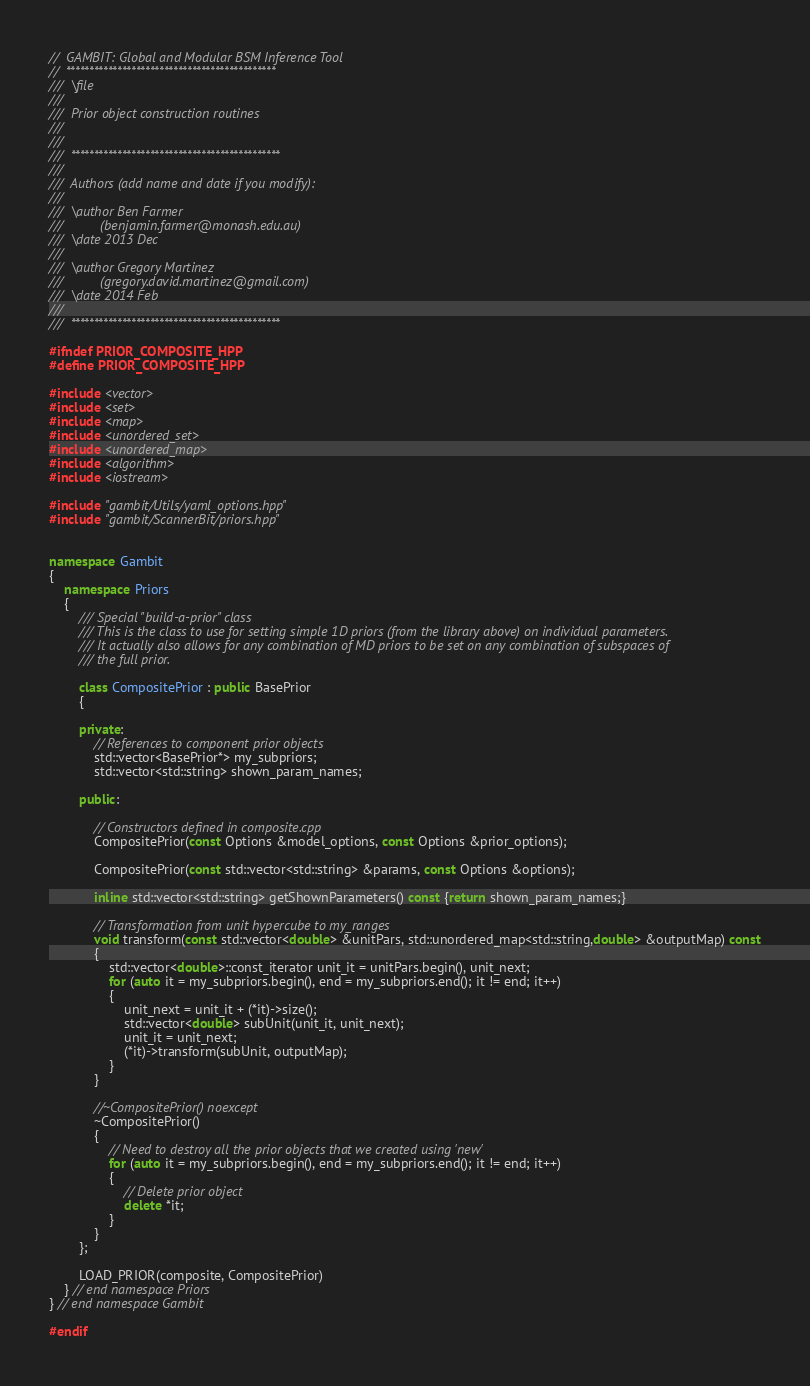Convert code to text. <code><loc_0><loc_0><loc_500><loc_500><_C++_>//  GAMBIT: Global and Modular BSM Inference Tool
//  *********************************************
///  \file
///
///  Prior object construction routines
///  
///
///  *********************************************
///
///  Authors (add name and date if you modify):
///   
///  \author Ben Farmer
///          (benjamin.farmer@monash.edu.au)
///  \date 2013 Dec
///
///  \author Gregory Martinez
///          (gregory.david.martinez@gmail.com)
///  \date 2014 Feb
///
///  *********************************************

#ifndef PRIOR_COMPOSITE_HPP
#define PRIOR_COMPOSITE_HPP

#include <vector>
#include <set>
#include <map>
#include <unordered_set>
#include <unordered_map>
#include <algorithm>
#include <iostream>

#include "gambit/Utils/yaml_options.hpp"
#include "gambit/ScannerBit/priors.hpp"


namespace Gambit 
{
    namespace Priors 
    {
        /// Special "build-a-prior" class
        /// This is the class to use for setting simple 1D priors (from the library above) on individual parameters.
        /// It actually also allows for any combination of MD priors to be set on any combination of subspaces of
        /// the full prior.

        class CompositePrior : public BasePrior
        {
                        
        private:
            // References to component prior objects
            std::vector<BasePrior*> my_subpriors;
            std::vector<std::string> shown_param_names;
                
        public:
        
            // Constructors defined in composite.cpp
            CompositePrior(const Options &model_options, const Options &prior_options);
            
            CompositePrior(const std::vector<std::string> &params, const Options &options);
            
            inline std::vector<std::string> getShownParameters() const {return shown_param_names;}
            
            // Transformation from unit hypercube to my_ranges
            void transform(const std::vector<double> &unitPars, std::unordered_map<std::string,double> &outputMap) const
            {
                std::vector<double>::const_iterator unit_it = unitPars.begin(), unit_next;
                for (auto it = my_subpriors.begin(), end = my_subpriors.end(); it != end; it++)
                {
                    unit_next = unit_it + (*it)->size();
                    std::vector<double> subUnit(unit_it, unit_next);
                    unit_it = unit_next;
                    (*it)->transform(subUnit, outputMap);
                }
            }
            
            //~CompositePrior() noexcept
            ~CompositePrior()
            {
                // Need to destroy all the prior objects that we created using 'new'
                for (auto it = my_subpriors.begin(), end = my_subpriors.end(); it != end; it++)
                {  
                    // Delete prior object
                    delete *it;
                }
            }  
        };
            
        LOAD_PRIOR(composite, CompositePrior)
    } // end namespace Priors
} // end namespace Gambit

#endif
</code> 